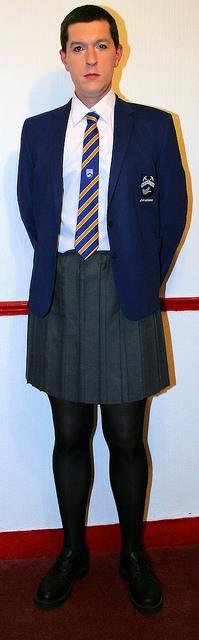What is the pattern on the person's tie?
Short answer required. Stripe. Is this man wearing pants?
Give a very brief answer. No. Is this a man?
Keep it brief. Yes. Is this person wearing leggings?
Short answer required. Yes. 